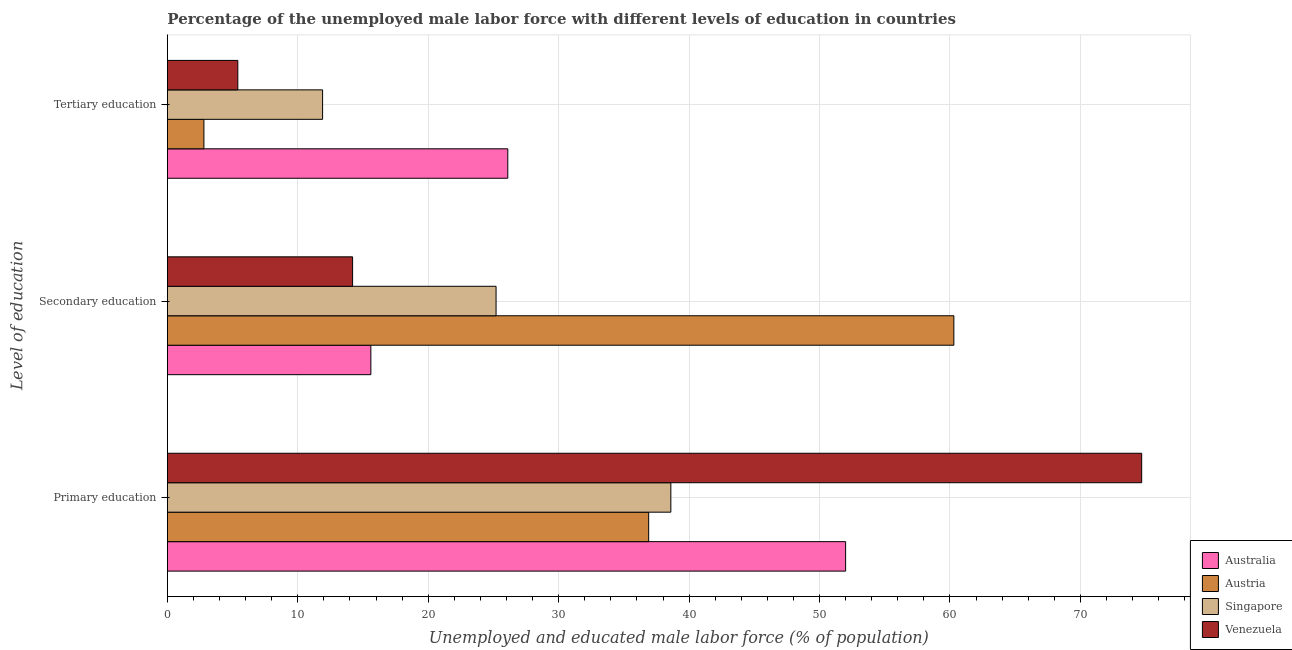Are the number of bars on each tick of the Y-axis equal?
Make the answer very short. Yes. How many bars are there on the 1st tick from the top?
Offer a very short reply. 4. How many bars are there on the 3rd tick from the bottom?
Provide a succinct answer. 4. What is the label of the 1st group of bars from the top?
Ensure brevity in your answer.  Tertiary education. What is the percentage of male labor force who received secondary education in Singapore?
Ensure brevity in your answer.  25.2. Across all countries, what is the maximum percentage of male labor force who received tertiary education?
Provide a succinct answer. 26.1. Across all countries, what is the minimum percentage of male labor force who received primary education?
Your response must be concise. 36.9. In which country was the percentage of male labor force who received tertiary education maximum?
Your response must be concise. Australia. What is the total percentage of male labor force who received primary education in the graph?
Ensure brevity in your answer.  202.2. What is the difference between the percentage of male labor force who received secondary education in Australia and that in Venezuela?
Your response must be concise. 1.4. What is the difference between the percentage of male labor force who received primary education in Singapore and the percentage of male labor force who received secondary education in Venezuela?
Provide a short and direct response. 24.4. What is the average percentage of male labor force who received primary education per country?
Make the answer very short. 50.55. What is the difference between the percentage of male labor force who received secondary education and percentage of male labor force who received tertiary education in Austria?
Your answer should be very brief. 57.5. In how many countries, is the percentage of male labor force who received secondary education greater than 12 %?
Ensure brevity in your answer.  4. What is the ratio of the percentage of male labor force who received secondary education in Austria to that in Singapore?
Give a very brief answer. 2.39. Is the percentage of male labor force who received primary education in Venezuela less than that in Austria?
Offer a very short reply. No. Is the difference between the percentage of male labor force who received primary education in Austria and Singapore greater than the difference between the percentage of male labor force who received secondary education in Austria and Singapore?
Provide a short and direct response. No. What is the difference between the highest and the second highest percentage of male labor force who received tertiary education?
Provide a succinct answer. 14.2. What is the difference between the highest and the lowest percentage of male labor force who received tertiary education?
Your response must be concise. 23.3. Is the sum of the percentage of male labor force who received primary education in Venezuela and Singapore greater than the maximum percentage of male labor force who received secondary education across all countries?
Offer a terse response. Yes. What does the 3rd bar from the top in Tertiary education represents?
Keep it short and to the point. Austria. What does the 4th bar from the bottom in Tertiary education represents?
Provide a succinct answer. Venezuela. Is it the case that in every country, the sum of the percentage of male labor force who received primary education and percentage of male labor force who received secondary education is greater than the percentage of male labor force who received tertiary education?
Offer a very short reply. Yes. How many bars are there?
Your answer should be very brief. 12. Does the graph contain any zero values?
Provide a short and direct response. No. How many legend labels are there?
Give a very brief answer. 4. What is the title of the graph?
Your answer should be compact. Percentage of the unemployed male labor force with different levels of education in countries. Does "High income: OECD" appear as one of the legend labels in the graph?
Make the answer very short. No. What is the label or title of the X-axis?
Offer a very short reply. Unemployed and educated male labor force (% of population). What is the label or title of the Y-axis?
Offer a terse response. Level of education. What is the Unemployed and educated male labor force (% of population) in Australia in Primary education?
Give a very brief answer. 52. What is the Unemployed and educated male labor force (% of population) in Austria in Primary education?
Offer a terse response. 36.9. What is the Unemployed and educated male labor force (% of population) in Singapore in Primary education?
Ensure brevity in your answer.  38.6. What is the Unemployed and educated male labor force (% of population) of Venezuela in Primary education?
Your answer should be compact. 74.7. What is the Unemployed and educated male labor force (% of population) of Australia in Secondary education?
Your answer should be compact. 15.6. What is the Unemployed and educated male labor force (% of population) of Austria in Secondary education?
Offer a terse response. 60.3. What is the Unemployed and educated male labor force (% of population) in Singapore in Secondary education?
Provide a succinct answer. 25.2. What is the Unemployed and educated male labor force (% of population) of Venezuela in Secondary education?
Give a very brief answer. 14.2. What is the Unemployed and educated male labor force (% of population) in Australia in Tertiary education?
Ensure brevity in your answer.  26.1. What is the Unemployed and educated male labor force (% of population) of Austria in Tertiary education?
Your answer should be very brief. 2.8. What is the Unemployed and educated male labor force (% of population) in Singapore in Tertiary education?
Ensure brevity in your answer.  11.9. What is the Unemployed and educated male labor force (% of population) of Venezuela in Tertiary education?
Offer a terse response. 5.4. Across all Level of education, what is the maximum Unemployed and educated male labor force (% of population) of Australia?
Your answer should be compact. 52. Across all Level of education, what is the maximum Unemployed and educated male labor force (% of population) in Austria?
Your answer should be very brief. 60.3. Across all Level of education, what is the maximum Unemployed and educated male labor force (% of population) in Singapore?
Provide a short and direct response. 38.6. Across all Level of education, what is the maximum Unemployed and educated male labor force (% of population) in Venezuela?
Provide a succinct answer. 74.7. Across all Level of education, what is the minimum Unemployed and educated male labor force (% of population) in Australia?
Offer a terse response. 15.6. Across all Level of education, what is the minimum Unemployed and educated male labor force (% of population) in Austria?
Offer a terse response. 2.8. Across all Level of education, what is the minimum Unemployed and educated male labor force (% of population) of Singapore?
Your answer should be compact. 11.9. Across all Level of education, what is the minimum Unemployed and educated male labor force (% of population) in Venezuela?
Keep it short and to the point. 5.4. What is the total Unemployed and educated male labor force (% of population) in Australia in the graph?
Provide a succinct answer. 93.7. What is the total Unemployed and educated male labor force (% of population) in Singapore in the graph?
Offer a terse response. 75.7. What is the total Unemployed and educated male labor force (% of population) in Venezuela in the graph?
Provide a succinct answer. 94.3. What is the difference between the Unemployed and educated male labor force (% of population) of Australia in Primary education and that in Secondary education?
Provide a short and direct response. 36.4. What is the difference between the Unemployed and educated male labor force (% of population) in Austria in Primary education and that in Secondary education?
Your answer should be compact. -23.4. What is the difference between the Unemployed and educated male labor force (% of population) in Singapore in Primary education and that in Secondary education?
Provide a succinct answer. 13.4. What is the difference between the Unemployed and educated male labor force (% of population) of Venezuela in Primary education and that in Secondary education?
Make the answer very short. 60.5. What is the difference between the Unemployed and educated male labor force (% of population) in Australia in Primary education and that in Tertiary education?
Your answer should be very brief. 25.9. What is the difference between the Unemployed and educated male labor force (% of population) of Austria in Primary education and that in Tertiary education?
Your response must be concise. 34.1. What is the difference between the Unemployed and educated male labor force (% of population) of Singapore in Primary education and that in Tertiary education?
Offer a very short reply. 26.7. What is the difference between the Unemployed and educated male labor force (% of population) of Venezuela in Primary education and that in Tertiary education?
Keep it short and to the point. 69.3. What is the difference between the Unemployed and educated male labor force (% of population) in Austria in Secondary education and that in Tertiary education?
Ensure brevity in your answer.  57.5. What is the difference between the Unemployed and educated male labor force (% of population) in Venezuela in Secondary education and that in Tertiary education?
Offer a very short reply. 8.8. What is the difference between the Unemployed and educated male labor force (% of population) in Australia in Primary education and the Unemployed and educated male labor force (% of population) in Singapore in Secondary education?
Provide a succinct answer. 26.8. What is the difference between the Unemployed and educated male labor force (% of population) in Australia in Primary education and the Unemployed and educated male labor force (% of population) in Venezuela in Secondary education?
Your answer should be very brief. 37.8. What is the difference between the Unemployed and educated male labor force (% of population) in Austria in Primary education and the Unemployed and educated male labor force (% of population) in Venezuela in Secondary education?
Your answer should be compact. 22.7. What is the difference between the Unemployed and educated male labor force (% of population) in Singapore in Primary education and the Unemployed and educated male labor force (% of population) in Venezuela in Secondary education?
Give a very brief answer. 24.4. What is the difference between the Unemployed and educated male labor force (% of population) of Australia in Primary education and the Unemployed and educated male labor force (% of population) of Austria in Tertiary education?
Make the answer very short. 49.2. What is the difference between the Unemployed and educated male labor force (% of population) of Australia in Primary education and the Unemployed and educated male labor force (% of population) of Singapore in Tertiary education?
Your answer should be very brief. 40.1. What is the difference between the Unemployed and educated male labor force (% of population) in Australia in Primary education and the Unemployed and educated male labor force (% of population) in Venezuela in Tertiary education?
Provide a short and direct response. 46.6. What is the difference between the Unemployed and educated male labor force (% of population) in Austria in Primary education and the Unemployed and educated male labor force (% of population) in Singapore in Tertiary education?
Offer a very short reply. 25. What is the difference between the Unemployed and educated male labor force (% of population) in Austria in Primary education and the Unemployed and educated male labor force (% of population) in Venezuela in Tertiary education?
Your answer should be compact. 31.5. What is the difference between the Unemployed and educated male labor force (% of population) of Singapore in Primary education and the Unemployed and educated male labor force (% of population) of Venezuela in Tertiary education?
Make the answer very short. 33.2. What is the difference between the Unemployed and educated male labor force (% of population) of Australia in Secondary education and the Unemployed and educated male labor force (% of population) of Venezuela in Tertiary education?
Provide a short and direct response. 10.2. What is the difference between the Unemployed and educated male labor force (% of population) in Austria in Secondary education and the Unemployed and educated male labor force (% of population) in Singapore in Tertiary education?
Keep it short and to the point. 48.4. What is the difference between the Unemployed and educated male labor force (% of population) of Austria in Secondary education and the Unemployed and educated male labor force (% of population) of Venezuela in Tertiary education?
Your answer should be very brief. 54.9. What is the difference between the Unemployed and educated male labor force (% of population) of Singapore in Secondary education and the Unemployed and educated male labor force (% of population) of Venezuela in Tertiary education?
Keep it short and to the point. 19.8. What is the average Unemployed and educated male labor force (% of population) in Australia per Level of education?
Make the answer very short. 31.23. What is the average Unemployed and educated male labor force (% of population) of Austria per Level of education?
Ensure brevity in your answer.  33.33. What is the average Unemployed and educated male labor force (% of population) in Singapore per Level of education?
Give a very brief answer. 25.23. What is the average Unemployed and educated male labor force (% of population) in Venezuela per Level of education?
Keep it short and to the point. 31.43. What is the difference between the Unemployed and educated male labor force (% of population) in Australia and Unemployed and educated male labor force (% of population) in Singapore in Primary education?
Keep it short and to the point. 13.4. What is the difference between the Unemployed and educated male labor force (% of population) in Australia and Unemployed and educated male labor force (% of population) in Venezuela in Primary education?
Give a very brief answer. -22.7. What is the difference between the Unemployed and educated male labor force (% of population) of Austria and Unemployed and educated male labor force (% of population) of Singapore in Primary education?
Offer a very short reply. -1.7. What is the difference between the Unemployed and educated male labor force (% of population) of Austria and Unemployed and educated male labor force (% of population) of Venezuela in Primary education?
Offer a terse response. -37.8. What is the difference between the Unemployed and educated male labor force (% of population) of Singapore and Unemployed and educated male labor force (% of population) of Venezuela in Primary education?
Your answer should be compact. -36.1. What is the difference between the Unemployed and educated male labor force (% of population) of Australia and Unemployed and educated male labor force (% of population) of Austria in Secondary education?
Your answer should be compact. -44.7. What is the difference between the Unemployed and educated male labor force (% of population) in Austria and Unemployed and educated male labor force (% of population) in Singapore in Secondary education?
Your answer should be compact. 35.1. What is the difference between the Unemployed and educated male labor force (% of population) of Austria and Unemployed and educated male labor force (% of population) of Venezuela in Secondary education?
Provide a short and direct response. 46.1. What is the difference between the Unemployed and educated male labor force (% of population) in Singapore and Unemployed and educated male labor force (% of population) in Venezuela in Secondary education?
Offer a terse response. 11. What is the difference between the Unemployed and educated male labor force (% of population) in Australia and Unemployed and educated male labor force (% of population) in Austria in Tertiary education?
Offer a very short reply. 23.3. What is the difference between the Unemployed and educated male labor force (% of population) in Australia and Unemployed and educated male labor force (% of population) in Venezuela in Tertiary education?
Your answer should be very brief. 20.7. What is the difference between the Unemployed and educated male labor force (% of population) in Singapore and Unemployed and educated male labor force (% of population) in Venezuela in Tertiary education?
Your answer should be very brief. 6.5. What is the ratio of the Unemployed and educated male labor force (% of population) of Australia in Primary education to that in Secondary education?
Provide a short and direct response. 3.33. What is the ratio of the Unemployed and educated male labor force (% of population) in Austria in Primary education to that in Secondary education?
Provide a succinct answer. 0.61. What is the ratio of the Unemployed and educated male labor force (% of population) of Singapore in Primary education to that in Secondary education?
Offer a very short reply. 1.53. What is the ratio of the Unemployed and educated male labor force (% of population) of Venezuela in Primary education to that in Secondary education?
Make the answer very short. 5.26. What is the ratio of the Unemployed and educated male labor force (% of population) in Australia in Primary education to that in Tertiary education?
Make the answer very short. 1.99. What is the ratio of the Unemployed and educated male labor force (% of population) in Austria in Primary education to that in Tertiary education?
Make the answer very short. 13.18. What is the ratio of the Unemployed and educated male labor force (% of population) in Singapore in Primary education to that in Tertiary education?
Ensure brevity in your answer.  3.24. What is the ratio of the Unemployed and educated male labor force (% of population) in Venezuela in Primary education to that in Tertiary education?
Your answer should be compact. 13.83. What is the ratio of the Unemployed and educated male labor force (% of population) of Australia in Secondary education to that in Tertiary education?
Give a very brief answer. 0.6. What is the ratio of the Unemployed and educated male labor force (% of population) of Austria in Secondary education to that in Tertiary education?
Make the answer very short. 21.54. What is the ratio of the Unemployed and educated male labor force (% of population) in Singapore in Secondary education to that in Tertiary education?
Offer a terse response. 2.12. What is the ratio of the Unemployed and educated male labor force (% of population) of Venezuela in Secondary education to that in Tertiary education?
Keep it short and to the point. 2.63. What is the difference between the highest and the second highest Unemployed and educated male labor force (% of population) of Australia?
Give a very brief answer. 25.9. What is the difference between the highest and the second highest Unemployed and educated male labor force (% of population) of Austria?
Offer a very short reply. 23.4. What is the difference between the highest and the second highest Unemployed and educated male labor force (% of population) in Singapore?
Your answer should be compact. 13.4. What is the difference between the highest and the second highest Unemployed and educated male labor force (% of population) in Venezuela?
Provide a succinct answer. 60.5. What is the difference between the highest and the lowest Unemployed and educated male labor force (% of population) of Australia?
Your answer should be compact. 36.4. What is the difference between the highest and the lowest Unemployed and educated male labor force (% of population) in Austria?
Your answer should be compact. 57.5. What is the difference between the highest and the lowest Unemployed and educated male labor force (% of population) in Singapore?
Make the answer very short. 26.7. What is the difference between the highest and the lowest Unemployed and educated male labor force (% of population) in Venezuela?
Offer a very short reply. 69.3. 